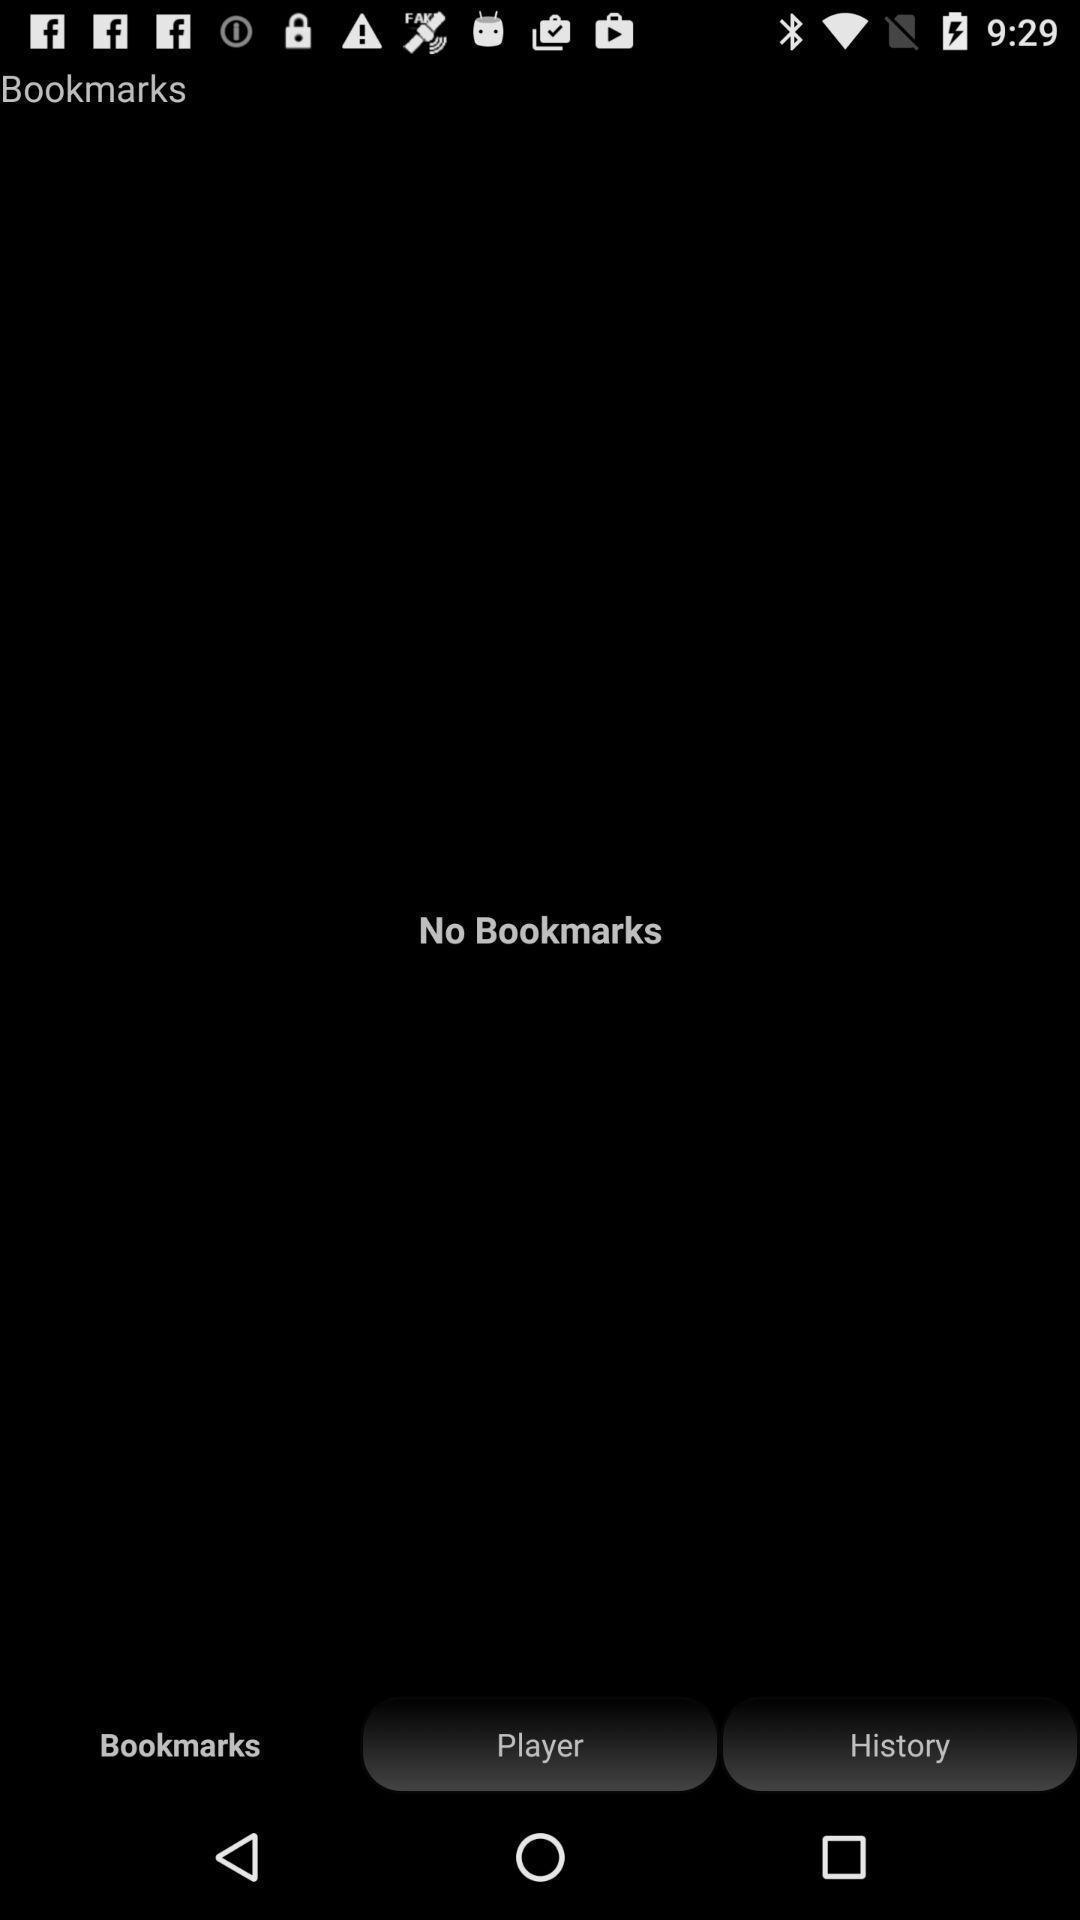Tell me about the visual elements in this screen capture. Screen displaying the bookmarks page which is empty. 